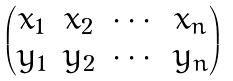<formula> <loc_0><loc_0><loc_500><loc_500>\begin{pmatrix} x _ { 1 } & x _ { 2 } & \cdots & x _ { n } \\ y _ { 1 } & y _ { 2 } & \cdots & y _ { n } \end{pmatrix}</formula> 